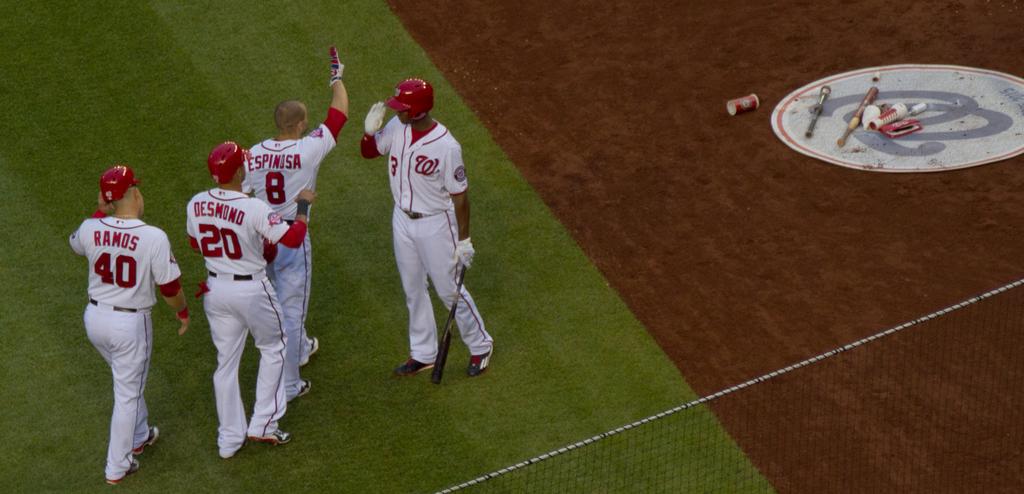What is the last name of the player number 40?
Ensure brevity in your answer.  Ramos. What is the number of the last player in line?
Make the answer very short. 40. 